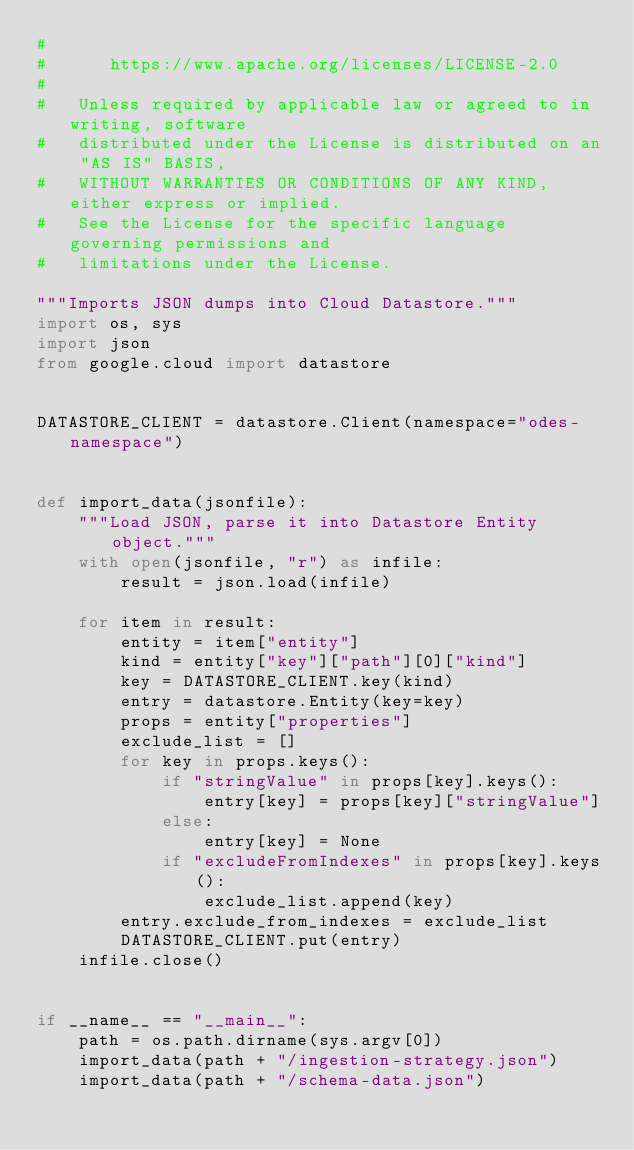<code> <loc_0><loc_0><loc_500><loc_500><_Python_>#
#      https://www.apache.org/licenses/LICENSE-2.0
#
#   Unless required by applicable law or agreed to in writing, software
#   distributed under the License is distributed on an "AS IS" BASIS,
#   WITHOUT WARRANTIES OR CONDITIONS OF ANY KIND, either express or implied.
#   See the License for the specific language governing permissions and
#   limitations under the License.

"""Imports JSON dumps into Cloud Datastore."""
import os, sys
import json
from google.cloud import datastore


DATASTORE_CLIENT = datastore.Client(namespace="odes-namespace")


def import_data(jsonfile):
    """Load JSON, parse it into Datastore Entity object."""
    with open(jsonfile, "r") as infile:
        result = json.load(infile)

    for item in result:
        entity = item["entity"]
        kind = entity["key"]["path"][0]["kind"]
        key = DATASTORE_CLIENT.key(kind)
        entry = datastore.Entity(key=key)
        props = entity["properties"]
        exclude_list = []
        for key in props.keys():
            if "stringValue" in props[key].keys():
                entry[key] = props[key]["stringValue"]
            else:
                entry[key] = None
            if "excludeFromIndexes" in props[key].keys():
                exclude_list.append(key)
        entry.exclude_from_indexes = exclude_list
        DATASTORE_CLIENT.put(entry)
    infile.close()


if __name__ == "__main__":
    path = os.path.dirname(sys.argv[0])
    import_data(path + "/ingestion-strategy.json")
    import_data(path + "/schema-data.json")
</code> 